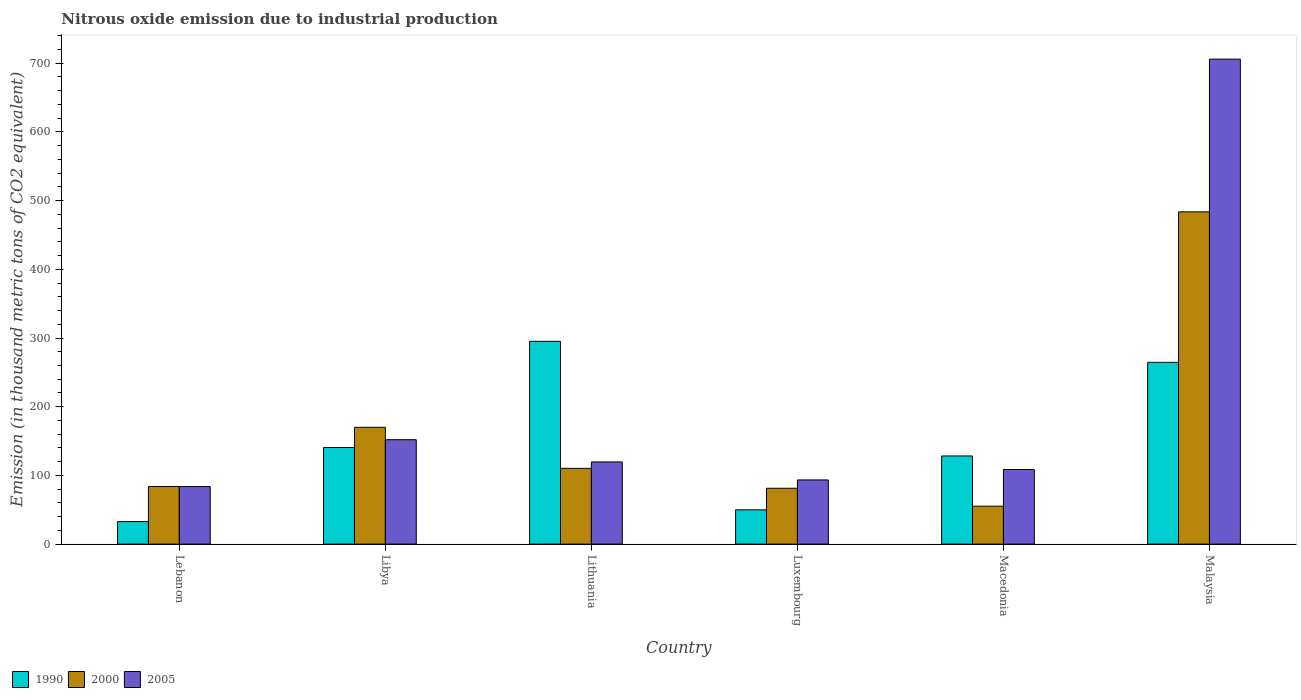How many different coloured bars are there?
Keep it short and to the point. 3. How many groups of bars are there?
Ensure brevity in your answer.  6. Are the number of bars per tick equal to the number of legend labels?
Ensure brevity in your answer.  Yes. Are the number of bars on each tick of the X-axis equal?
Give a very brief answer. Yes. How many bars are there on the 5th tick from the left?
Keep it short and to the point. 3. How many bars are there on the 2nd tick from the right?
Your response must be concise. 3. What is the label of the 6th group of bars from the left?
Provide a short and direct response. Malaysia. What is the amount of nitrous oxide emitted in 2005 in Macedonia?
Provide a short and direct response. 108.6. Across all countries, what is the maximum amount of nitrous oxide emitted in 2000?
Ensure brevity in your answer.  483.7. Across all countries, what is the minimum amount of nitrous oxide emitted in 2005?
Make the answer very short. 83.7. In which country was the amount of nitrous oxide emitted in 1990 maximum?
Provide a short and direct response. Lithuania. In which country was the amount of nitrous oxide emitted in 1990 minimum?
Your answer should be compact. Lebanon. What is the total amount of nitrous oxide emitted in 2005 in the graph?
Offer a very short reply. 1263.3. What is the difference between the amount of nitrous oxide emitted in 2000 in Lithuania and that in Macedonia?
Offer a very short reply. 55.1. What is the difference between the amount of nitrous oxide emitted in 2000 in Luxembourg and the amount of nitrous oxide emitted in 1990 in Malaysia?
Ensure brevity in your answer.  -183.3. What is the average amount of nitrous oxide emitted in 2000 per country?
Provide a succinct answer. 164.05. What is the difference between the amount of nitrous oxide emitted of/in 2000 and amount of nitrous oxide emitted of/in 2005 in Malaysia?
Give a very brief answer. -222.3. In how many countries, is the amount of nitrous oxide emitted in 1990 greater than 720 thousand metric tons?
Your answer should be compact. 0. What is the ratio of the amount of nitrous oxide emitted in 2005 in Luxembourg to that in Macedonia?
Provide a succinct answer. 0.86. Is the amount of nitrous oxide emitted in 2005 in Macedonia less than that in Malaysia?
Provide a short and direct response. Yes. What is the difference between the highest and the second highest amount of nitrous oxide emitted in 2005?
Make the answer very short. -554. What is the difference between the highest and the lowest amount of nitrous oxide emitted in 2000?
Your response must be concise. 428.5. In how many countries, is the amount of nitrous oxide emitted in 1990 greater than the average amount of nitrous oxide emitted in 1990 taken over all countries?
Offer a very short reply. 2. Is the sum of the amount of nitrous oxide emitted in 2000 in Macedonia and Malaysia greater than the maximum amount of nitrous oxide emitted in 2005 across all countries?
Your response must be concise. No. What does the 2nd bar from the left in Malaysia represents?
Make the answer very short. 2000. Is it the case that in every country, the sum of the amount of nitrous oxide emitted in 2000 and amount of nitrous oxide emitted in 2005 is greater than the amount of nitrous oxide emitted in 1990?
Offer a terse response. No. Are all the bars in the graph horizontal?
Your answer should be very brief. No. How many countries are there in the graph?
Give a very brief answer. 6. What is the difference between two consecutive major ticks on the Y-axis?
Your answer should be compact. 100. Does the graph contain grids?
Offer a very short reply. No. Where does the legend appear in the graph?
Offer a terse response. Bottom left. What is the title of the graph?
Make the answer very short. Nitrous oxide emission due to industrial production. What is the label or title of the X-axis?
Make the answer very short. Country. What is the label or title of the Y-axis?
Offer a very short reply. Emission (in thousand metric tons of CO2 equivalent). What is the Emission (in thousand metric tons of CO2 equivalent) in 1990 in Lebanon?
Offer a terse response. 32.8. What is the Emission (in thousand metric tons of CO2 equivalent) in 2000 in Lebanon?
Ensure brevity in your answer.  83.8. What is the Emission (in thousand metric tons of CO2 equivalent) of 2005 in Lebanon?
Make the answer very short. 83.7. What is the Emission (in thousand metric tons of CO2 equivalent) in 1990 in Libya?
Make the answer very short. 140.6. What is the Emission (in thousand metric tons of CO2 equivalent) in 2000 in Libya?
Your answer should be very brief. 170. What is the Emission (in thousand metric tons of CO2 equivalent) of 2005 in Libya?
Make the answer very short. 152. What is the Emission (in thousand metric tons of CO2 equivalent) of 1990 in Lithuania?
Give a very brief answer. 295.2. What is the Emission (in thousand metric tons of CO2 equivalent) in 2000 in Lithuania?
Your response must be concise. 110.3. What is the Emission (in thousand metric tons of CO2 equivalent) in 2005 in Lithuania?
Your answer should be compact. 119.6. What is the Emission (in thousand metric tons of CO2 equivalent) in 1990 in Luxembourg?
Provide a succinct answer. 49.9. What is the Emission (in thousand metric tons of CO2 equivalent) in 2000 in Luxembourg?
Offer a terse response. 81.3. What is the Emission (in thousand metric tons of CO2 equivalent) of 2005 in Luxembourg?
Make the answer very short. 93.4. What is the Emission (in thousand metric tons of CO2 equivalent) in 1990 in Macedonia?
Offer a terse response. 128.3. What is the Emission (in thousand metric tons of CO2 equivalent) of 2000 in Macedonia?
Provide a short and direct response. 55.2. What is the Emission (in thousand metric tons of CO2 equivalent) in 2005 in Macedonia?
Make the answer very short. 108.6. What is the Emission (in thousand metric tons of CO2 equivalent) of 1990 in Malaysia?
Give a very brief answer. 264.6. What is the Emission (in thousand metric tons of CO2 equivalent) of 2000 in Malaysia?
Your response must be concise. 483.7. What is the Emission (in thousand metric tons of CO2 equivalent) of 2005 in Malaysia?
Your response must be concise. 706. Across all countries, what is the maximum Emission (in thousand metric tons of CO2 equivalent) in 1990?
Offer a very short reply. 295.2. Across all countries, what is the maximum Emission (in thousand metric tons of CO2 equivalent) in 2000?
Provide a succinct answer. 483.7. Across all countries, what is the maximum Emission (in thousand metric tons of CO2 equivalent) of 2005?
Keep it short and to the point. 706. Across all countries, what is the minimum Emission (in thousand metric tons of CO2 equivalent) in 1990?
Your response must be concise. 32.8. Across all countries, what is the minimum Emission (in thousand metric tons of CO2 equivalent) in 2000?
Make the answer very short. 55.2. Across all countries, what is the minimum Emission (in thousand metric tons of CO2 equivalent) in 2005?
Keep it short and to the point. 83.7. What is the total Emission (in thousand metric tons of CO2 equivalent) of 1990 in the graph?
Make the answer very short. 911.4. What is the total Emission (in thousand metric tons of CO2 equivalent) of 2000 in the graph?
Offer a very short reply. 984.3. What is the total Emission (in thousand metric tons of CO2 equivalent) of 2005 in the graph?
Your answer should be compact. 1263.3. What is the difference between the Emission (in thousand metric tons of CO2 equivalent) of 1990 in Lebanon and that in Libya?
Offer a terse response. -107.8. What is the difference between the Emission (in thousand metric tons of CO2 equivalent) of 2000 in Lebanon and that in Libya?
Provide a short and direct response. -86.2. What is the difference between the Emission (in thousand metric tons of CO2 equivalent) of 2005 in Lebanon and that in Libya?
Ensure brevity in your answer.  -68.3. What is the difference between the Emission (in thousand metric tons of CO2 equivalent) in 1990 in Lebanon and that in Lithuania?
Keep it short and to the point. -262.4. What is the difference between the Emission (in thousand metric tons of CO2 equivalent) of 2000 in Lebanon and that in Lithuania?
Ensure brevity in your answer.  -26.5. What is the difference between the Emission (in thousand metric tons of CO2 equivalent) of 2005 in Lebanon and that in Lithuania?
Keep it short and to the point. -35.9. What is the difference between the Emission (in thousand metric tons of CO2 equivalent) of 1990 in Lebanon and that in Luxembourg?
Keep it short and to the point. -17.1. What is the difference between the Emission (in thousand metric tons of CO2 equivalent) in 2000 in Lebanon and that in Luxembourg?
Make the answer very short. 2.5. What is the difference between the Emission (in thousand metric tons of CO2 equivalent) in 1990 in Lebanon and that in Macedonia?
Your answer should be very brief. -95.5. What is the difference between the Emission (in thousand metric tons of CO2 equivalent) in 2000 in Lebanon and that in Macedonia?
Keep it short and to the point. 28.6. What is the difference between the Emission (in thousand metric tons of CO2 equivalent) in 2005 in Lebanon and that in Macedonia?
Your response must be concise. -24.9. What is the difference between the Emission (in thousand metric tons of CO2 equivalent) of 1990 in Lebanon and that in Malaysia?
Ensure brevity in your answer.  -231.8. What is the difference between the Emission (in thousand metric tons of CO2 equivalent) of 2000 in Lebanon and that in Malaysia?
Provide a short and direct response. -399.9. What is the difference between the Emission (in thousand metric tons of CO2 equivalent) of 2005 in Lebanon and that in Malaysia?
Ensure brevity in your answer.  -622.3. What is the difference between the Emission (in thousand metric tons of CO2 equivalent) in 1990 in Libya and that in Lithuania?
Ensure brevity in your answer.  -154.6. What is the difference between the Emission (in thousand metric tons of CO2 equivalent) of 2000 in Libya and that in Lithuania?
Keep it short and to the point. 59.7. What is the difference between the Emission (in thousand metric tons of CO2 equivalent) in 2005 in Libya and that in Lithuania?
Offer a very short reply. 32.4. What is the difference between the Emission (in thousand metric tons of CO2 equivalent) of 1990 in Libya and that in Luxembourg?
Provide a succinct answer. 90.7. What is the difference between the Emission (in thousand metric tons of CO2 equivalent) of 2000 in Libya and that in Luxembourg?
Your answer should be very brief. 88.7. What is the difference between the Emission (in thousand metric tons of CO2 equivalent) in 2005 in Libya and that in Luxembourg?
Your answer should be compact. 58.6. What is the difference between the Emission (in thousand metric tons of CO2 equivalent) in 1990 in Libya and that in Macedonia?
Offer a very short reply. 12.3. What is the difference between the Emission (in thousand metric tons of CO2 equivalent) of 2000 in Libya and that in Macedonia?
Ensure brevity in your answer.  114.8. What is the difference between the Emission (in thousand metric tons of CO2 equivalent) of 2005 in Libya and that in Macedonia?
Your answer should be very brief. 43.4. What is the difference between the Emission (in thousand metric tons of CO2 equivalent) of 1990 in Libya and that in Malaysia?
Give a very brief answer. -124. What is the difference between the Emission (in thousand metric tons of CO2 equivalent) of 2000 in Libya and that in Malaysia?
Ensure brevity in your answer.  -313.7. What is the difference between the Emission (in thousand metric tons of CO2 equivalent) of 2005 in Libya and that in Malaysia?
Your response must be concise. -554. What is the difference between the Emission (in thousand metric tons of CO2 equivalent) in 1990 in Lithuania and that in Luxembourg?
Keep it short and to the point. 245.3. What is the difference between the Emission (in thousand metric tons of CO2 equivalent) in 2005 in Lithuania and that in Luxembourg?
Keep it short and to the point. 26.2. What is the difference between the Emission (in thousand metric tons of CO2 equivalent) of 1990 in Lithuania and that in Macedonia?
Your response must be concise. 166.9. What is the difference between the Emission (in thousand metric tons of CO2 equivalent) in 2000 in Lithuania and that in Macedonia?
Your answer should be compact. 55.1. What is the difference between the Emission (in thousand metric tons of CO2 equivalent) of 1990 in Lithuania and that in Malaysia?
Keep it short and to the point. 30.6. What is the difference between the Emission (in thousand metric tons of CO2 equivalent) in 2000 in Lithuania and that in Malaysia?
Your answer should be very brief. -373.4. What is the difference between the Emission (in thousand metric tons of CO2 equivalent) of 2005 in Lithuania and that in Malaysia?
Your response must be concise. -586.4. What is the difference between the Emission (in thousand metric tons of CO2 equivalent) in 1990 in Luxembourg and that in Macedonia?
Give a very brief answer. -78.4. What is the difference between the Emission (in thousand metric tons of CO2 equivalent) of 2000 in Luxembourg and that in Macedonia?
Keep it short and to the point. 26.1. What is the difference between the Emission (in thousand metric tons of CO2 equivalent) of 2005 in Luxembourg and that in Macedonia?
Your answer should be compact. -15.2. What is the difference between the Emission (in thousand metric tons of CO2 equivalent) in 1990 in Luxembourg and that in Malaysia?
Keep it short and to the point. -214.7. What is the difference between the Emission (in thousand metric tons of CO2 equivalent) of 2000 in Luxembourg and that in Malaysia?
Offer a terse response. -402.4. What is the difference between the Emission (in thousand metric tons of CO2 equivalent) in 2005 in Luxembourg and that in Malaysia?
Offer a terse response. -612.6. What is the difference between the Emission (in thousand metric tons of CO2 equivalent) in 1990 in Macedonia and that in Malaysia?
Provide a short and direct response. -136.3. What is the difference between the Emission (in thousand metric tons of CO2 equivalent) in 2000 in Macedonia and that in Malaysia?
Make the answer very short. -428.5. What is the difference between the Emission (in thousand metric tons of CO2 equivalent) in 2005 in Macedonia and that in Malaysia?
Give a very brief answer. -597.4. What is the difference between the Emission (in thousand metric tons of CO2 equivalent) in 1990 in Lebanon and the Emission (in thousand metric tons of CO2 equivalent) in 2000 in Libya?
Provide a short and direct response. -137.2. What is the difference between the Emission (in thousand metric tons of CO2 equivalent) of 1990 in Lebanon and the Emission (in thousand metric tons of CO2 equivalent) of 2005 in Libya?
Your response must be concise. -119.2. What is the difference between the Emission (in thousand metric tons of CO2 equivalent) of 2000 in Lebanon and the Emission (in thousand metric tons of CO2 equivalent) of 2005 in Libya?
Your answer should be very brief. -68.2. What is the difference between the Emission (in thousand metric tons of CO2 equivalent) in 1990 in Lebanon and the Emission (in thousand metric tons of CO2 equivalent) in 2000 in Lithuania?
Provide a succinct answer. -77.5. What is the difference between the Emission (in thousand metric tons of CO2 equivalent) of 1990 in Lebanon and the Emission (in thousand metric tons of CO2 equivalent) of 2005 in Lithuania?
Offer a very short reply. -86.8. What is the difference between the Emission (in thousand metric tons of CO2 equivalent) in 2000 in Lebanon and the Emission (in thousand metric tons of CO2 equivalent) in 2005 in Lithuania?
Provide a short and direct response. -35.8. What is the difference between the Emission (in thousand metric tons of CO2 equivalent) of 1990 in Lebanon and the Emission (in thousand metric tons of CO2 equivalent) of 2000 in Luxembourg?
Offer a very short reply. -48.5. What is the difference between the Emission (in thousand metric tons of CO2 equivalent) of 1990 in Lebanon and the Emission (in thousand metric tons of CO2 equivalent) of 2005 in Luxembourg?
Give a very brief answer. -60.6. What is the difference between the Emission (in thousand metric tons of CO2 equivalent) in 2000 in Lebanon and the Emission (in thousand metric tons of CO2 equivalent) in 2005 in Luxembourg?
Your answer should be very brief. -9.6. What is the difference between the Emission (in thousand metric tons of CO2 equivalent) in 1990 in Lebanon and the Emission (in thousand metric tons of CO2 equivalent) in 2000 in Macedonia?
Ensure brevity in your answer.  -22.4. What is the difference between the Emission (in thousand metric tons of CO2 equivalent) in 1990 in Lebanon and the Emission (in thousand metric tons of CO2 equivalent) in 2005 in Macedonia?
Offer a terse response. -75.8. What is the difference between the Emission (in thousand metric tons of CO2 equivalent) of 2000 in Lebanon and the Emission (in thousand metric tons of CO2 equivalent) of 2005 in Macedonia?
Make the answer very short. -24.8. What is the difference between the Emission (in thousand metric tons of CO2 equivalent) of 1990 in Lebanon and the Emission (in thousand metric tons of CO2 equivalent) of 2000 in Malaysia?
Offer a very short reply. -450.9. What is the difference between the Emission (in thousand metric tons of CO2 equivalent) of 1990 in Lebanon and the Emission (in thousand metric tons of CO2 equivalent) of 2005 in Malaysia?
Keep it short and to the point. -673.2. What is the difference between the Emission (in thousand metric tons of CO2 equivalent) in 2000 in Lebanon and the Emission (in thousand metric tons of CO2 equivalent) in 2005 in Malaysia?
Offer a very short reply. -622.2. What is the difference between the Emission (in thousand metric tons of CO2 equivalent) of 1990 in Libya and the Emission (in thousand metric tons of CO2 equivalent) of 2000 in Lithuania?
Offer a very short reply. 30.3. What is the difference between the Emission (in thousand metric tons of CO2 equivalent) of 2000 in Libya and the Emission (in thousand metric tons of CO2 equivalent) of 2005 in Lithuania?
Give a very brief answer. 50.4. What is the difference between the Emission (in thousand metric tons of CO2 equivalent) of 1990 in Libya and the Emission (in thousand metric tons of CO2 equivalent) of 2000 in Luxembourg?
Your answer should be very brief. 59.3. What is the difference between the Emission (in thousand metric tons of CO2 equivalent) in 1990 in Libya and the Emission (in thousand metric tons of CO2 equivalent) in 2005 in Luxembourg?
Provide a succinct answer. 47.2. What is the difference between the Emission (in thousand metric tons of CO2 equivalent) in 2000 in Libya and the Emission (in thousand metric tons of CO2 equivalent) in 2005 in Luxembourg?
Offer a terse response. 76.6. What is the difference between the Emission (in thousand metric tons of CO2 equivalent) in 1990 in Libya and the Emission (in thousand metric tons of CO2 equivalent) in 2000 in Macedonia?
Ensure brevity in your answer.  85.4. What is the difference between the Emission (in thousand metric tons of CO2 equivalent) in 2000 in Libya and the Emission (in thousand metric tons of CO2 equivalent) in 2005 in Macedonia?
Ensure brevity in your answer.  61.4. What is the difference between the Emission (in thousand metric tons of CO2 equivalent) in 1990 in Libya and the Emission (in thousand metric tons of CO2 equivalent) in 2000 in Malaysia?
Make the answer very short. -343.1. What is the difference between the Emission (in thousand metric tons of CO2 equivalent) in 1990 in Libya and the Emission (in thousand metric tons of CO2 equivalent) in 2005 in Malaysia?
Offer a very short reply. -565.4. What is the difference between the Emission (in thousand metric tons of CO2 equivalent) in 2000 in Libya and the Emission (in thousand metric tons of CO2 equivalent) in 2005 in Malaysia?
Make the answer very short. -536. What is the difference between the Emission (in thousand metric tons of CO2 equivalent) in 1990 in Lithuania and the Emission (in thousand metric tons of CO2 equivalent) in 2000 in Luxembourg?
Your answer should be compact. 213.9. What is the difference between the Emission (in thousand metric tons of CO2 equivalent) of 1990 in Lithuania and the Emission (in thousand metric tons of CO2 equivalent) of 2005 in Luxembourg?
Your answer should be compact. 201.8. What is the difference between the Emission (in thousand metric tons of CO2 equivalent) of 1990 in Lithuania and the Emission (in thousand metric tons of CO2 equivalent) of 2000 in Macedonia?
Make the answer very short. 240. What is the difference between the Emission (in thousand metric tons of CO2 equivalent) in 1990 in Lithuania and the Emission (in thousand metric tons of CO2 equivalent) in 2005 in Macedonia?
Provide a short and direct response. 186.6. What is the difference between the Emission (in thousand metric tons of CO2 equivalent) of 1990 in Lithuania and the Emission (in thousand metric tons of CO2 equivalent) of 2000 in Malaysia?
Provide a short and direct response. -188.5. What is the difference between the Emission (in thousand metric tons of CO2 equivalent) in 1990 in Lithuania and the Emission (in thousand metric tons of CO2 equivalent) in 2005 in Malaysia?
Your response must be concise. -410.8. What is the difference between the Emission (in thousand metric tons of CO2 equivalent) of 2000 in Lithuania and the Emission (in thousand metric tons of CO2 equivalent) of 2005 in Malaysia?
Give a very brief answer. -595.7. What is the difference between the Emission (in thousand metric tons of CO2 equivalent) in 1990 in Luxembourg and the Emission (in thousand metric tons of CO2 equivalent) in 2005 in Macedonia?
Ensure brevity in your answer.  -58.7. What is the difference between the Emission (in thousand metric tons of CO2 equivalent) in 2000 in Luxembourg and the Emission (in thousand metric tons of CO2 equivalent) in 2005 in Macedonia?
Provide a succinct answer. -27.3. What is the difference between the Emission (in thousand metric tons of CO2 equivalent) in 1990 in Luxembourg and the Emission (in thousand metric tons of CO2 equivalent) in 2000 in Malaysia?
Your answer should be very brief. -433.8. What is the difference between the Emission (in thousand metric tons of CO2 equivalent) in 1990 in Luxembourg and the Emission (in thousand metric tons of CO2 equivalent) in 2005 in Malaysia?
Your response must be concise. -656.1. What is the difference between the Emission (in thousand metric tons of CO2 equivalent) of 2000 in Luxembourg and the Emission (in thousand metric tons of CO2 equivalent) of 2005 in Malaysia?
Ensure brevity in your answer.  -624.7. What is the difference between the Emission (in thousand metric tons of CO2 equivalent) of 1990 in Macedonia and the Emission (in thousand metric tons of CO2 equivalent) of 2000 in Malaysia?
Your answer should be very brief. -355.4. What is the difference between the Emission (in thousand metric tons of CO2 equivalent) of 1990 in Macedonia and the Emission (in thousand metric tons of CO2 equivalent) of 2005 in Malaysia?
Provide a short and direct response. -577.7. What is the difference between the Emission (in thousand metric tons of CO2 equivalent) in 2000 in Macedonia and the Emission (in thousand metric tons of CO2 equivalent) in 2005 in Malaysia?
Provide a short and direct response. -650.8. What is the average Emission (in thousand metric tons of CO2 equivalent) in 1990 per country?
Your answer should be very brief. 151.9. What is the average Emission (in thousand metric tons of CO2 equivalent) in 2000 per country?
Your answer should be compact. 164.05. What is the average Emission (in thousand metric tons of CO2 equivalent) in 2005 per country?
Offer a very short reply. 210.55. What is the difference between the Emission (in thousand metric tons of CO2 equivalent) in 1990 and Emission (in thousand metric tons of CO2 equivalent) in 2000 in Lebanon?
Provide a succinct answer. -51. What is the difference between the Emission (in thousand metric tons of CO2 equivalent) of 1990 and Emission (in thousand metric tons of CO2 equivalent) of 2005 in Lebanon?
Give a very brief answer. -50.9. What is the difference between the Emission (in thousand metric tons of CO2 equivalent) of 1990 and Emission (in thousand metric tons of CO2 equivalent) of 2000 in Libya?
Your answer should be compact. -29.4. What is the difference between the Emission (in thousand metric tons of CO2 equivalent) of 1990 and Emission (in thousand metric tons of CO2 equivalent) of 2000 in Lithuania?
Your answer should be compact. 184.9. What is the difference between the Emission (in thousand metric tons of CO2 equivalent) in 1990 and Emission (in thousand metric tons of CO2 equivalent) in 2005 in Lithuania?
Provide a succinct answer. 175.6. What is the difference between the Emission (in thousand metric tons of CO2 equivalent) of 1990 and Emission (in thousand metric tons of CO2 equivalent) of 2000 in Luxembourg?
Make the answer very short. -31.4. What is the difference between the Emission (in thousand metric tons of CO2 equivalent) of 1990 and Emission (in thousand metric tons of CO2 equivalent) of 2005 in Luxembourg?
Your answer should be compact. -43.5. What is the difference between the Emission (in thousand metric tons of CO2 equivalent) in 2000 and Emission (in thousand metric tons of CO2 equivalent) in 2005 in Luxembourg?
Your answer should be compact. -12.1. What is the difference between the Emission (in thousand metric tons of CO2 equivalent) of 1990 and Emission (in thousand metric tons of CO2 equivalent) of 2000 in Macedonia?
Give a very brief answer. 73.1. What is the difference between the Emission (in thousand metric tons of CO2 equivalent) of 1990 and Emission (in thousand metric tons of CO2 equivalent) of 2005 in Macedonia?
Ensure brevity in your answer.  19.7. What is the difference between the Emission (in thousand metric tons of CO2 equivalent) in 2000 and Emission (in thousand metric tons of CO2 equivalent) in 2005 in Macedonia?
Provide a succinct answer. -53.4. What is the difference between the Emission (in thousand metric tons of CO2 equivalent) in 1990 and Emission (in thousand metric tons of CO2 equivalent) in 2000 in Malaysia?
Your answer should be compact. -219.1. What is the difference between the Emission (in thousand metric tons of CO2 equivalent) in 1990 and Emission (in thousand metric tons of CO2 equivalent) in 2005 in Malaysia?
Offer a terse response. -441.4. What is the difference between the Emission (in thousand metric tons of CO2 equivalent) of 2000 and Emission (in thousand metric tons of CO2 equivalent) of 2005 in Malaysia?
Provide a succinct answer. -222.3. What is the ratio of the Emission (in thousand metric tons of CO2 equivalent) in 1990 in Lebanon to that in Libya?
Your response must be concise. 0.23. What is the ratio of the Emission (in thousand metric tons of CO2 equivalent) in 2000 in Lebanon to that in Libya?
Offer a very short reply. 0.49. What is the ratio of the Emission (in thousand metric tons of CO2 equivalent) of 2005 in Lebanon to that in Libya?
Make the answer very short. 0.55. What is the ratio of the Emission (in thousand metric tons of CO2 equivalent) of 2000 in Lebanon to that in Lithuania?
Give a very brief answer. 0.76. What is the ratio of the Emission (in thousand metric tons of CO2 equivalent) in 2005 in Lebanon to that in Lithuania?
Make the answer very short. 0.7. What is the ratio of the Emission (in thousand metric tons of CO2 equivalent) of 1990 in Lebanon to that in Luxembourg?
Give a very brief answer. 0.66. What is the ratio of the Emission (in thousand metric tons of CO2 equivalent) in 2000 in Lebanon to that in Luxembourg?
Ensure brevity in your answer.  1.03. What is the ratio of the Emission (in thousand metric tons of CO2 equivalent) in 2005 in Lebanon to that in Luxembourg?
Make the answer very short. 0.9. What is the ratio of the Emission (in thousand metric tons of CO2 equivalent) in 1990 in Lebanon to that in Macedonia?
Your answer should be very brief. 0.26. What is the ratio of the Emission (in thousand metric tons of CO2 equivalent) in 2000 in Lebanon to that in Macedonia?
Your answer should be very brief. 1.52. What is the ratio of the Emission (in thousand metric tons of CO2 equivalent) in 2005 in Lebanon to that in Macedonia?
Offer a very short reply. 0.77. What is the ratio of the Emission (in thousand metric tons of CO2 equivalent) of 1990 in Lebanon to that in Malaysia?
Offer a terse response. 0.12. What is the ratio of the Emission (in thousand metric tons of CO2 equivalent) of 2000 in Lebanon to that in Malaysia?
Your answer should be compact. 0.17. What is the ratio of the Emission (in thousand metric tons of CO2 equivalent) in 2005 in Lebanon to that in Malaysia?
Your response must be concise. 0.12. What is the ratio of the Emission (in thousand metric tons of CO2 equivalent) in 1990 in Libya to that in Lithuania?
Provide a short and direct response. 0.48. What is the ratio of the Emission (in thousand metric tons of CO2 equivalent) in 2000 in Libya to that in Lithuania?
Offer a terse response. 1.54. What is the ratio of the Emission (in thousand metric tons of CO2 equivalent) of 2005 in Libya to that in Lithuania?
Your response must be concise. 1.27. What is the ratio of the Emission (in thousand metric tons of CO2 equivalent) of 1990 in Libya to that in Luxembourg?
Your answer should be very brief. 2.82. What is the ratio of the Emission (in thousand metric tons of CO2 equivalent) in 2000 in Libya to that in Luxembourg?
Offer a terse response. 2.09. What is the ratio of the Emission (in thousand metric tons of CO2 equivalent) of 2005 in Libya to that in Luxembourg?
Provide a short and direct response. 1.63. What is the ratio of the Emission (in thousand metric tons of CO2 equivalent) in 1990 in Libya to that in Macedonia?
Your answer should be very brief. 1.1. What is the ratio of the Emission (in thousand metric tons of CO2 equivalent) of 2000 in Libya to that in Macedonia?
Provide a succinct answer. 3.08. What is the ratio of the Emission (in thousand metric tons of CO2 equivalent) in 2005 in Libya to that in Macedonia?
Make the answer very short. 1.4. What is the ratio of the Emission (in thousand metric tons of CO2 equivalent) of 1990 in Libya to that in Malaysia?
Keep it short and to the point. 0.53. What is the ratio of the Emission (in thousand metric tons of CO2 equivalent) in 2000 in Libya to that in Malaysia?
Give a very brief answer. 0.35. What is the ratio of the Emission (in thousand metric tons of CO2 equivalent) of 2005 in Libya to that in Malaysia?
Your response must be concise. 0.22. What is the ratio of the Emission (in thousand metric tons of CO2 equivalent) of 1990 in Lithuania to that in Luxembourg?
Give a very brief answer. 5.92. What is the ratio of the Emission (in thousand metric tons of CO2 equivalent) in 2000 in Lithuania to that in Luxembourg?
Offer a very short reply. 1.36. What is the ratio of the Emission (in thousand metric tons of CO2 equivalent) of 2005 in Lithuania to that in Luxembourg?
Your response must be concise. 1.28. What is the ratio of the Emission (in thousand metric tons of CO2 equivalent) of 1990 in Lithuania to that in Macedonia?
Give a very brief answer. 2.3. What is the ratio of the Emission (in thousand metric tons of CO2 equivalent) of 2000 in Lithuania to that in Macedonia?
Offer a very short reply. 2. What is the ratio of the Emission (in thousand metric tons of CO2 equivalent) in 2005 in Lithuania to that in Macedonia?
Keep it short and to the point. 1.1. What is the ratio of the Emission (in thousand metric tons of CO2 equivalent) in 1990 in Lithuania to that in Malaysia?
Offer a very short reply. 1.12. What is the ratio of the Emission (in thousand metric tons of CO2 equivalent) of 2000 in Lithuania to that in Malaysia?
Your answer should be compact. 0.23. What is the ratio of the Emission (in thousand metric tons of CO2 equivalent) in 2005 in Lithuania to that in Malaysia?
Offer a terse response. 0.17. What is the ratio of the Emission (in thousand metric tons of CO2 equivalent) in 1990 in Luxembourg to that in Macedonia?
Ensure brevity in your answer.  0.39. What is the ratio of the Emission (in thousand metric tons of CO2 equivalent) in 2000 in Luxembourg to that in Macedonia?
Ensure brevity in your answer.  1.47. What is the ratio of the Emission (in thousand metric tons of CO2 equivalent) of 2005 in Luxembourg to that in Macedonia?
Offer a very short reply. 0.86. What is the ratio of the Emission (in thousand metric tons of CO2 equivalent) of 1990 in Luxembourg to that in Malaysia?
Your answer should be very brief. 0.19. What is the ratio of the Emission (in thousand metric tons of CO2 equivalent) in 2000 in Luxembourg to that in Malaysia?
Give a very brief answer. 0.17. What is the ratio of the Emission (in thousand metric tons of CO2 equivalent) of 2005 in Luxembourg to that in Malaysia?
Give a very brief answer. 0.13. What is the ratio of the Emission (in thousand metric tons of CO2 equivalent) of 1990 in Macedonia to that in Malaysia?
Offer a terse response. 0.48. What is the ratio of the Emission (in thousand metric tons of CO2 equivalent) of 2000 in Macedonia to that in Malaysia?
Your answer should be very brief. 0.11. What is the ratio of the Emission (in thousand metric tons of CO2 equivalent) of 2005 in Macedonia to that in Malaysia?
Provide a succinct answer. 0.15. What is the difference between the highest and the second highest Emission (in thousand metric tons of CO2 equivalent) of 1990?
Give a very brief answer. 30.6. What is the difference between the highest and the second highest Emission (in thousand metric tons of CO2 equivalent) of 2000?
Your answer should be compact. 313.7. What is the difference between the highest and the second highest Emission (in thousand metric tons of CO2 equivalent) in 2005?
Your answer should be very brief. 554. What is the difference between the highest and the lowest Emission (in thousand metric tons of CO2 equivalent) of 1990?
Offer a very short reply. 262.4. What is the difference between the highest and the lowest Emission (in thousand metric tons of CO2 equivalent) in 2000?
Your answer should be compact. 428.5. What is the difference between the highest and the lowest Emission (in thousand metric tons of CO2 equivalent) in 2005?
Make the answer very short. 622.3. 